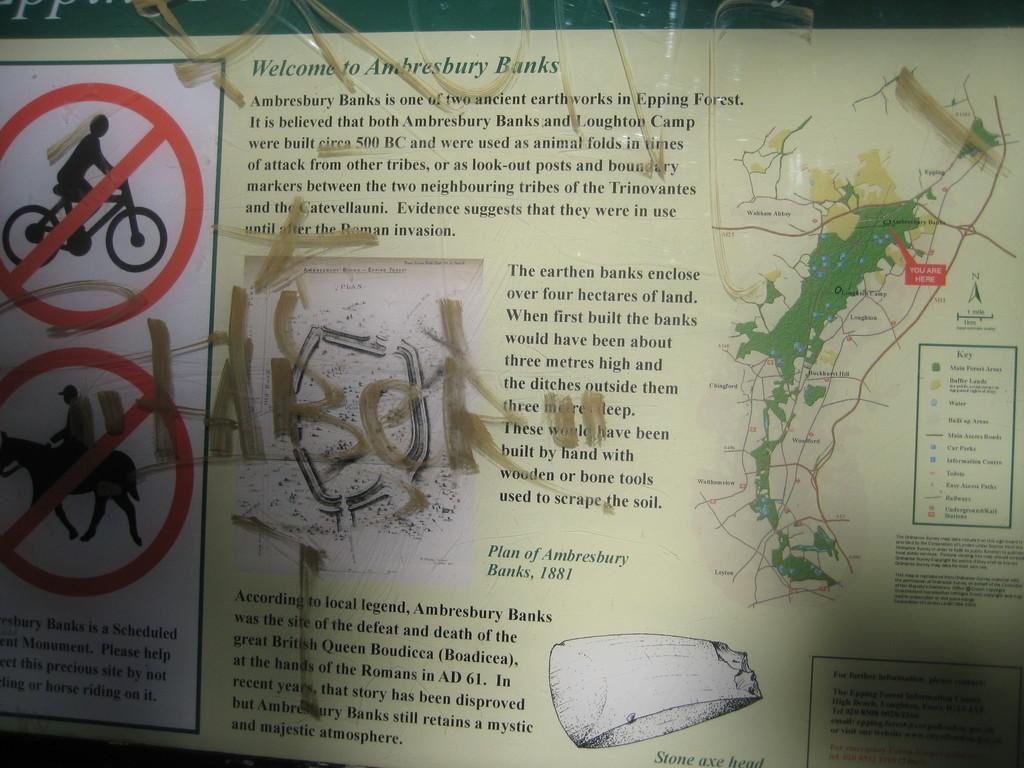<image>
Share a concise interpretation of the image provided. Board telling people not to bike or hose and says "Welcome to Ambresbury Banks". 